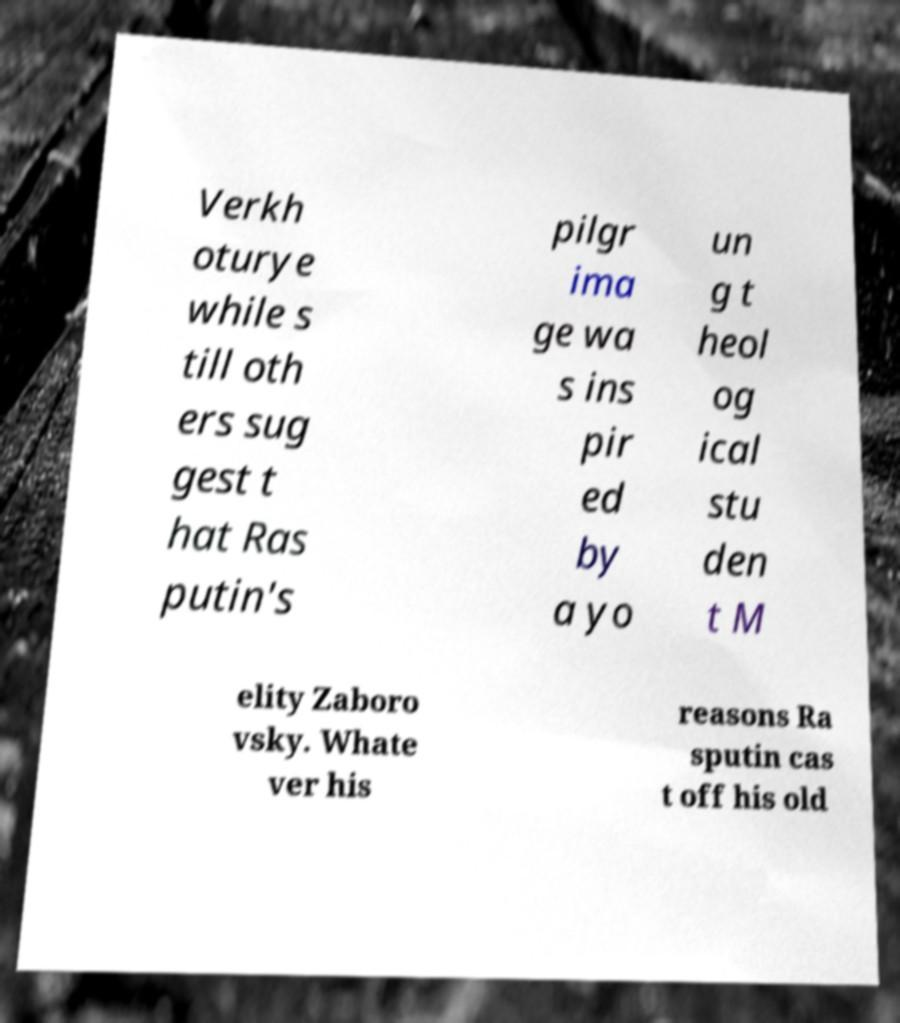Please read and relay the text visible in this image. What does it say? Verkh oturye while s till oth ers sug gest t hat Ras putin's pilgr ima ge wa s ins pir ed by a yo un g t heol og ical stu den t M elity Zaboro vsky. Whate ver his reasons Ra sputin cas t off his old 